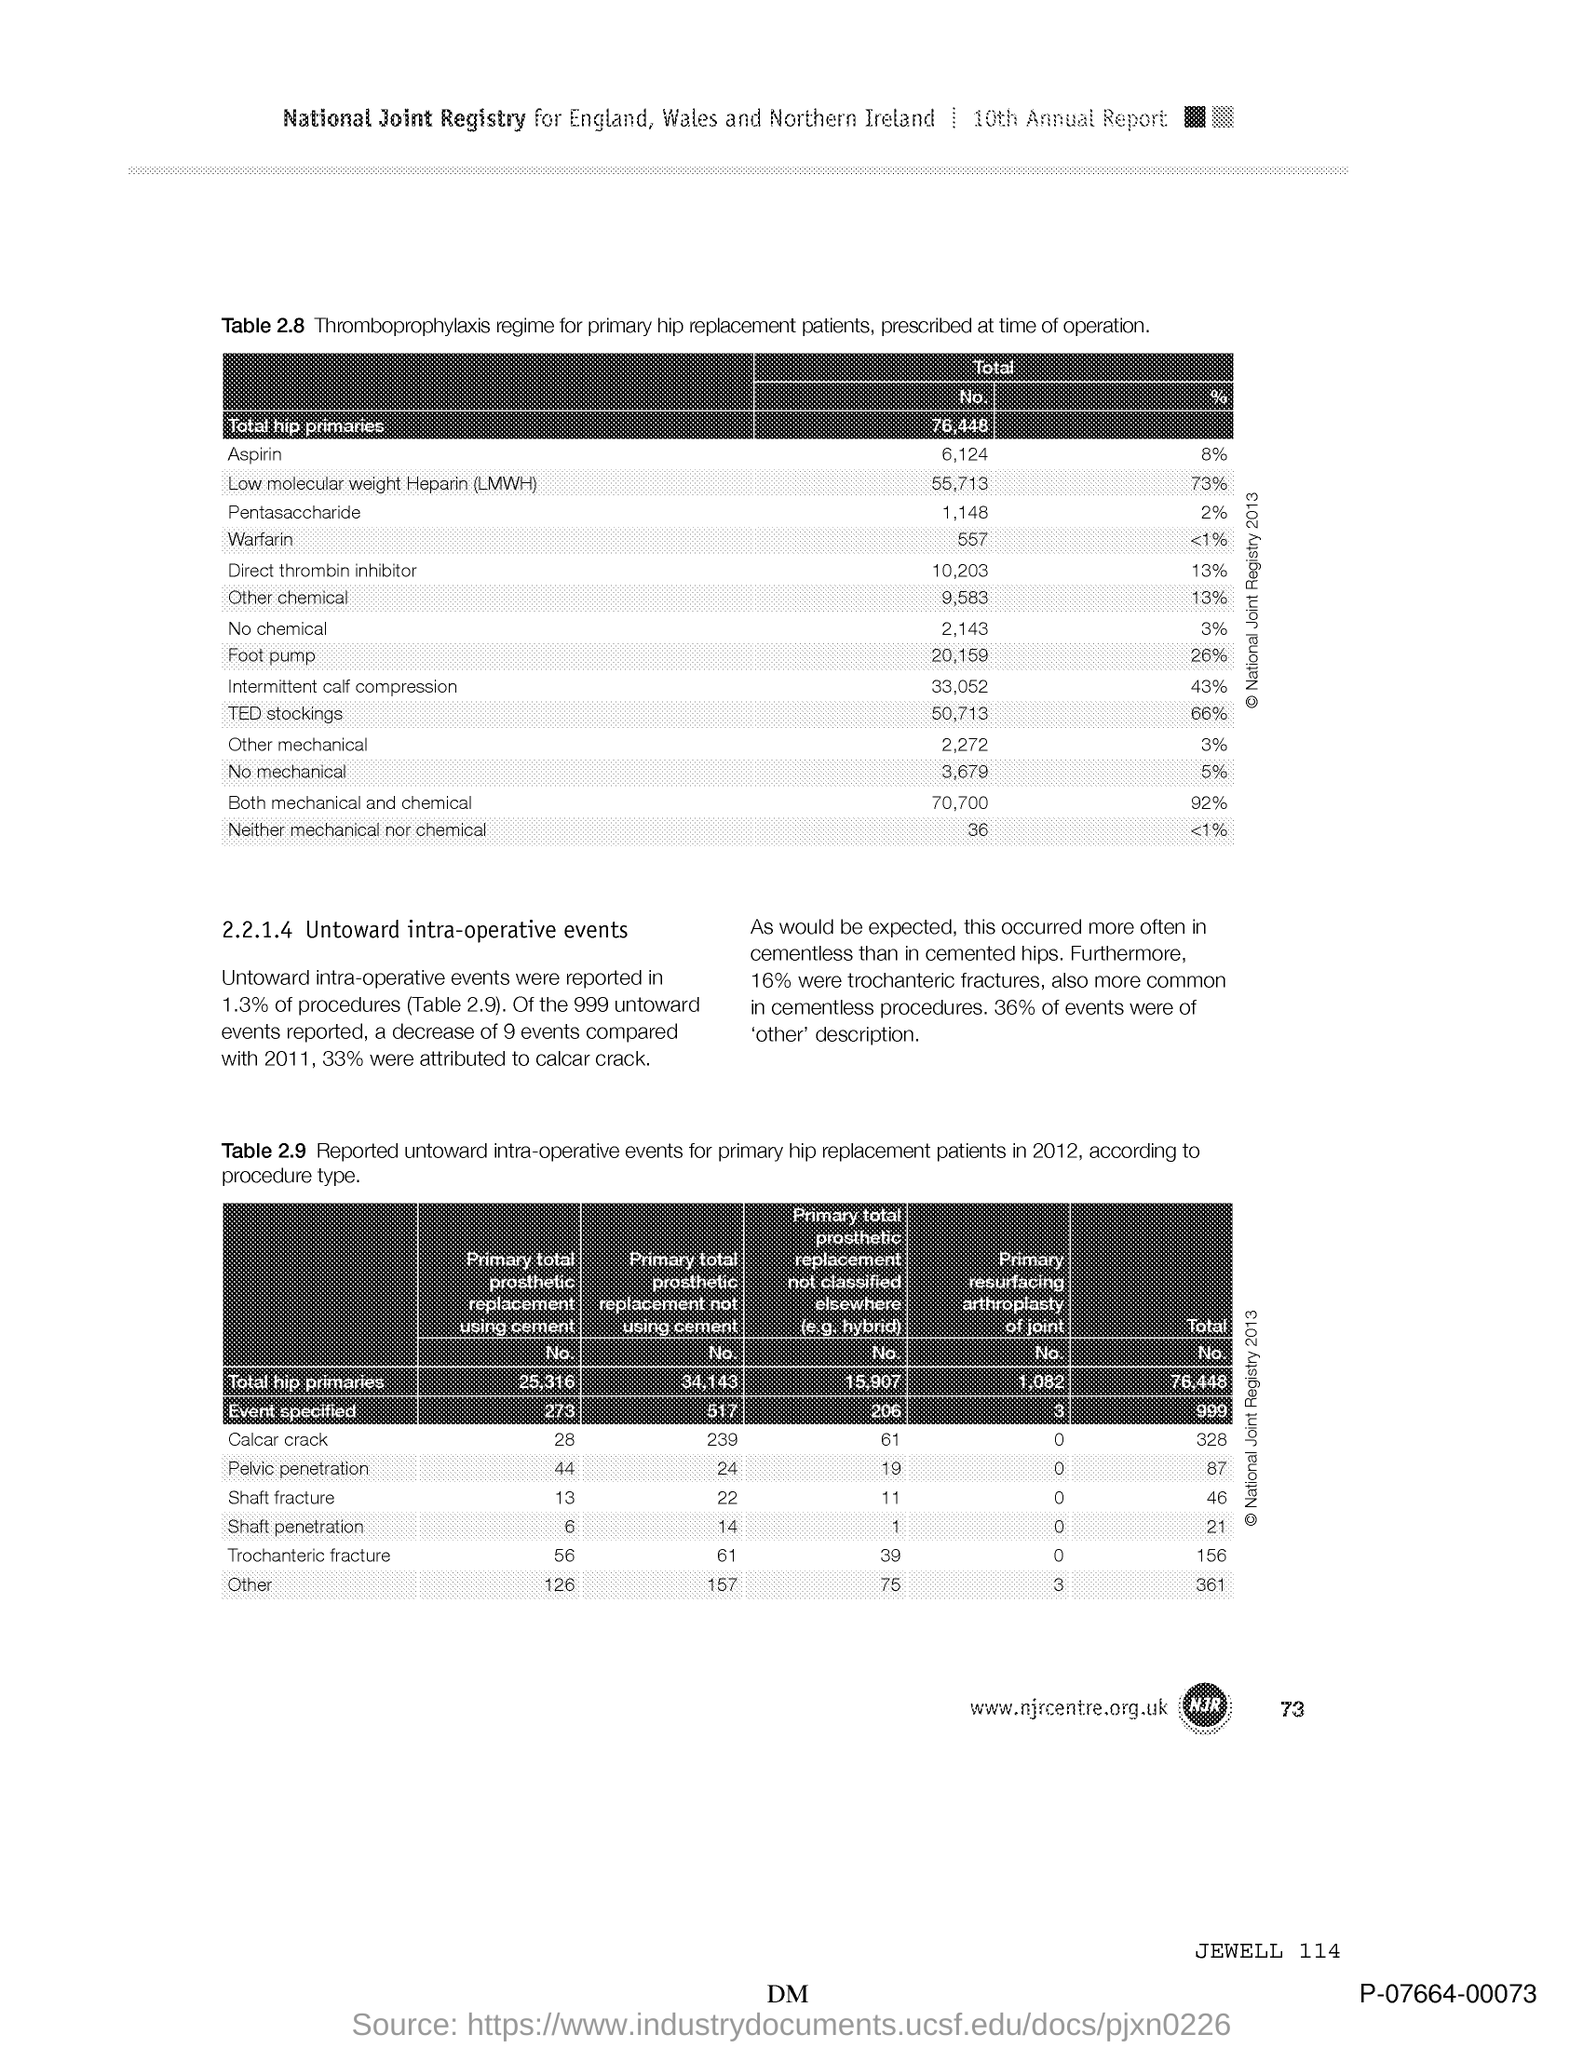Which edition of Annual Report is mentioned in the document?
Give a very brief answer. 10th Annual Report. What is the total number of hip primaries?
Offer a very short reply. 76,448. 